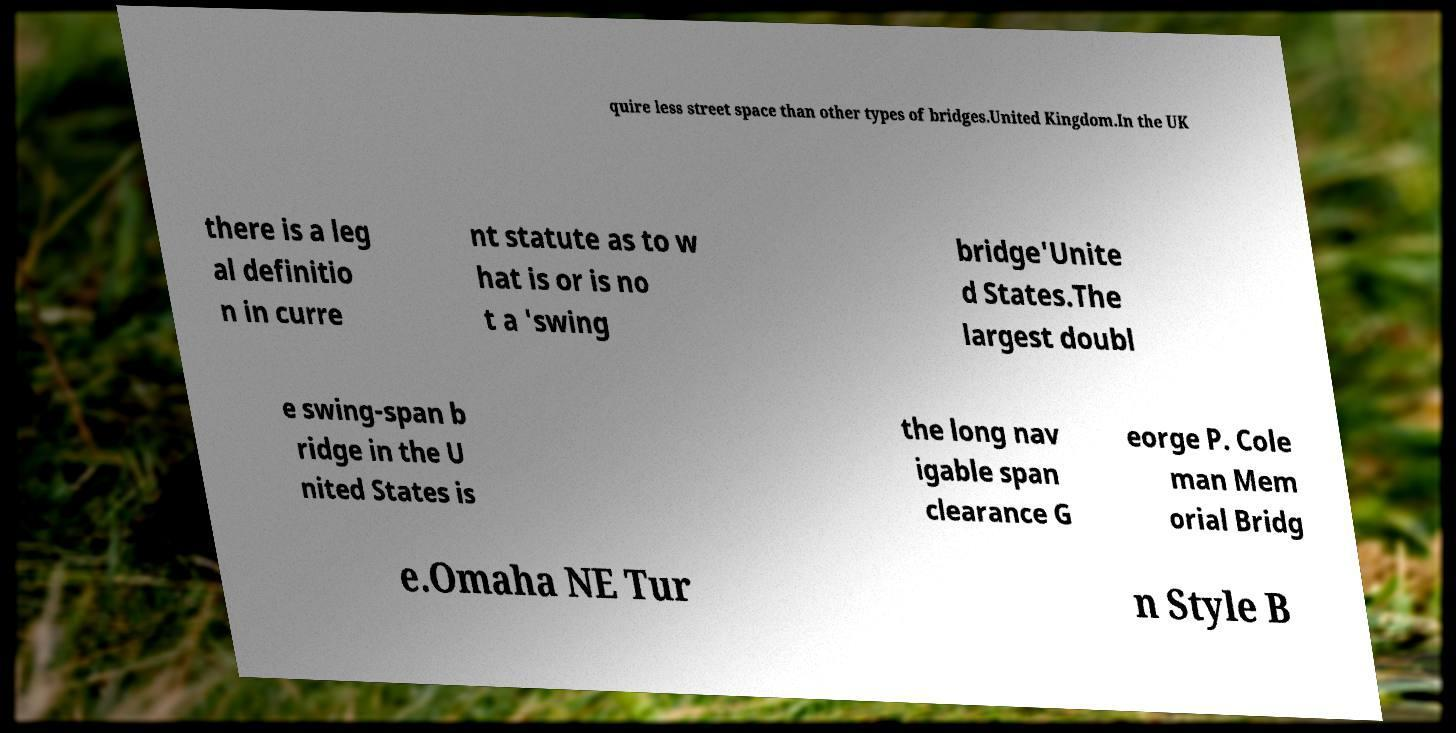There's text embedded in this image that I need extracted. Can you transcribe it verbatim? quire less street space than other types of bridges.United Kingdom.In the UK there is a leg al definitio n in curre nt statute as to w hat is or is no t a 'swing bridge'Unite d States.The largest doubl e swing-span b ridge in the U nited States is the long nav igable span clearance G eorge P. Cole man Mem orial Bridg e.Omaha NE Tur n Style B 